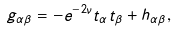<formula> <loc_0><loc_0><loc_500><loc_500>g _ { \alpha \beta } = - e ^ { - 2 \nu } t _ { \alpha } t _ { \beta } + h _ { \alpha \beta } ,</formula> 